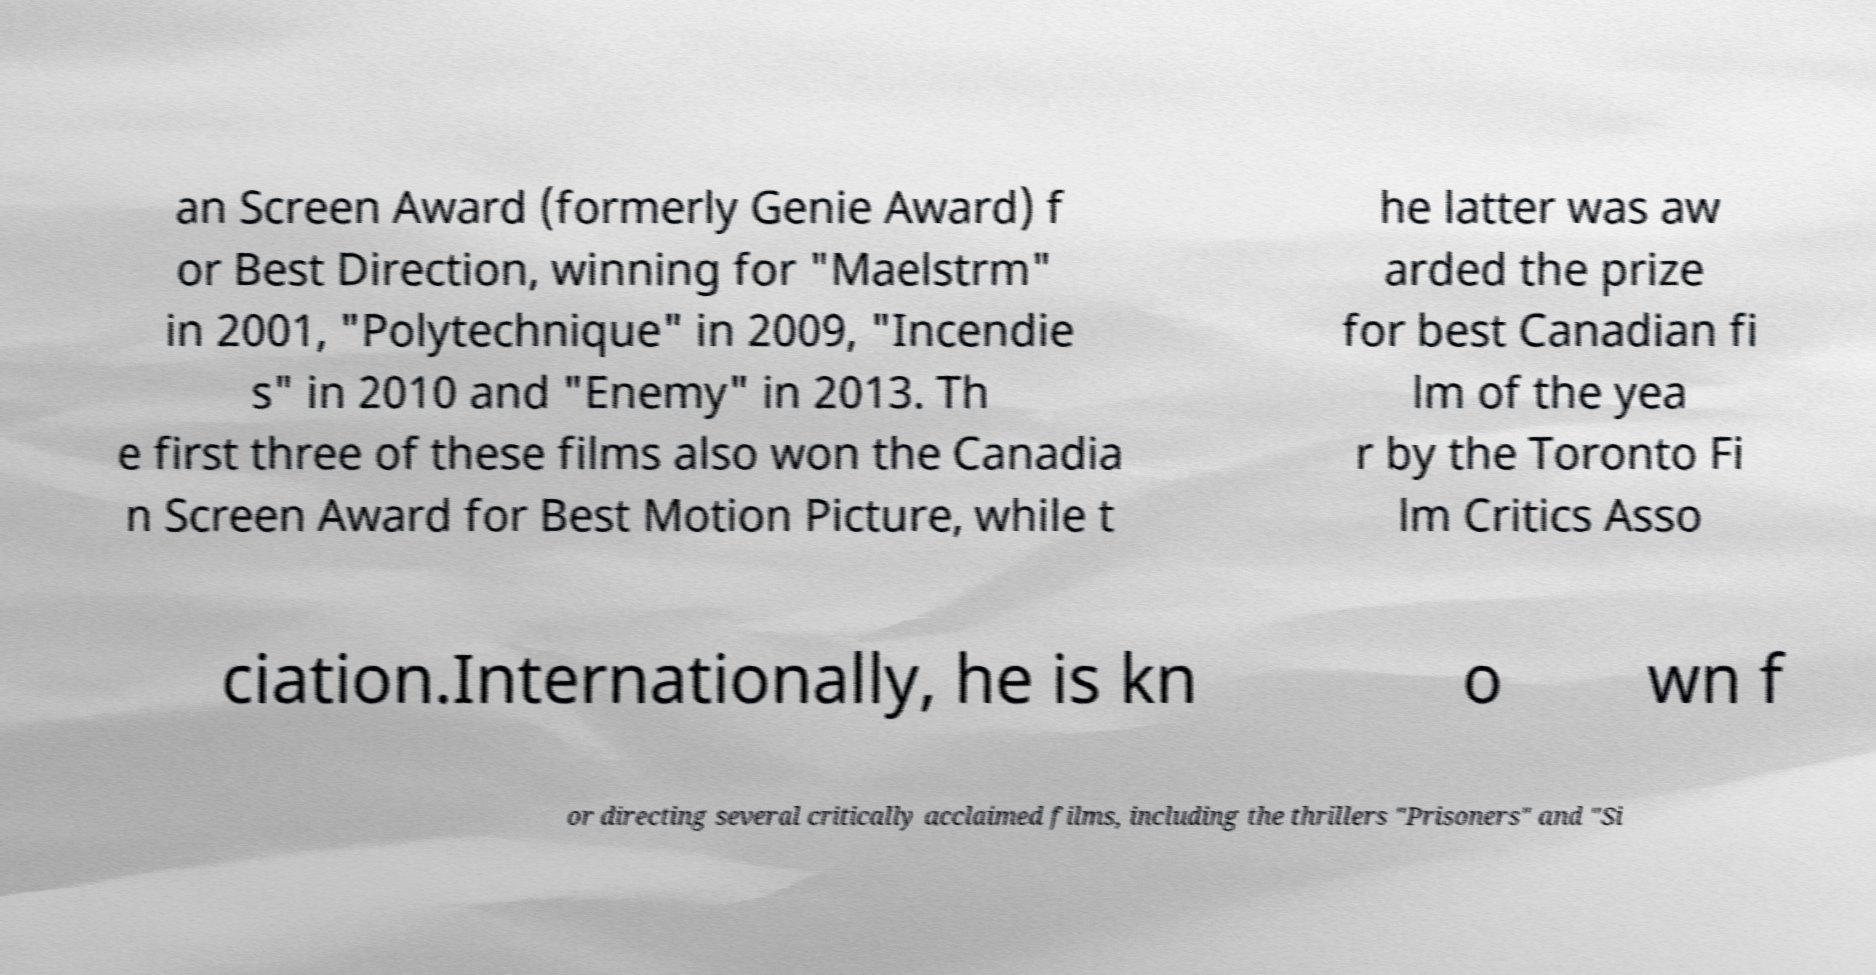Could you extract and type out the text from this image? an Screen Award (formerly Genie Award) f or Best Direction, winning for "Maelstrm" in 2001, "Polytechnique" in 2009, "Incendie s" in 2010 and "Enemy" in 2013. Th e first three of these films also won the Canadia n Screen Award for Best Motion Picture, while t he latter was aw arded the prize for best Canadian fi lm of the yea r by the Toronto Fi lm Critics Asso ciation.Internationally, he is kn o wn f or directing several critically acclaimed films, including the thrillers "Prisoners" and "Si 